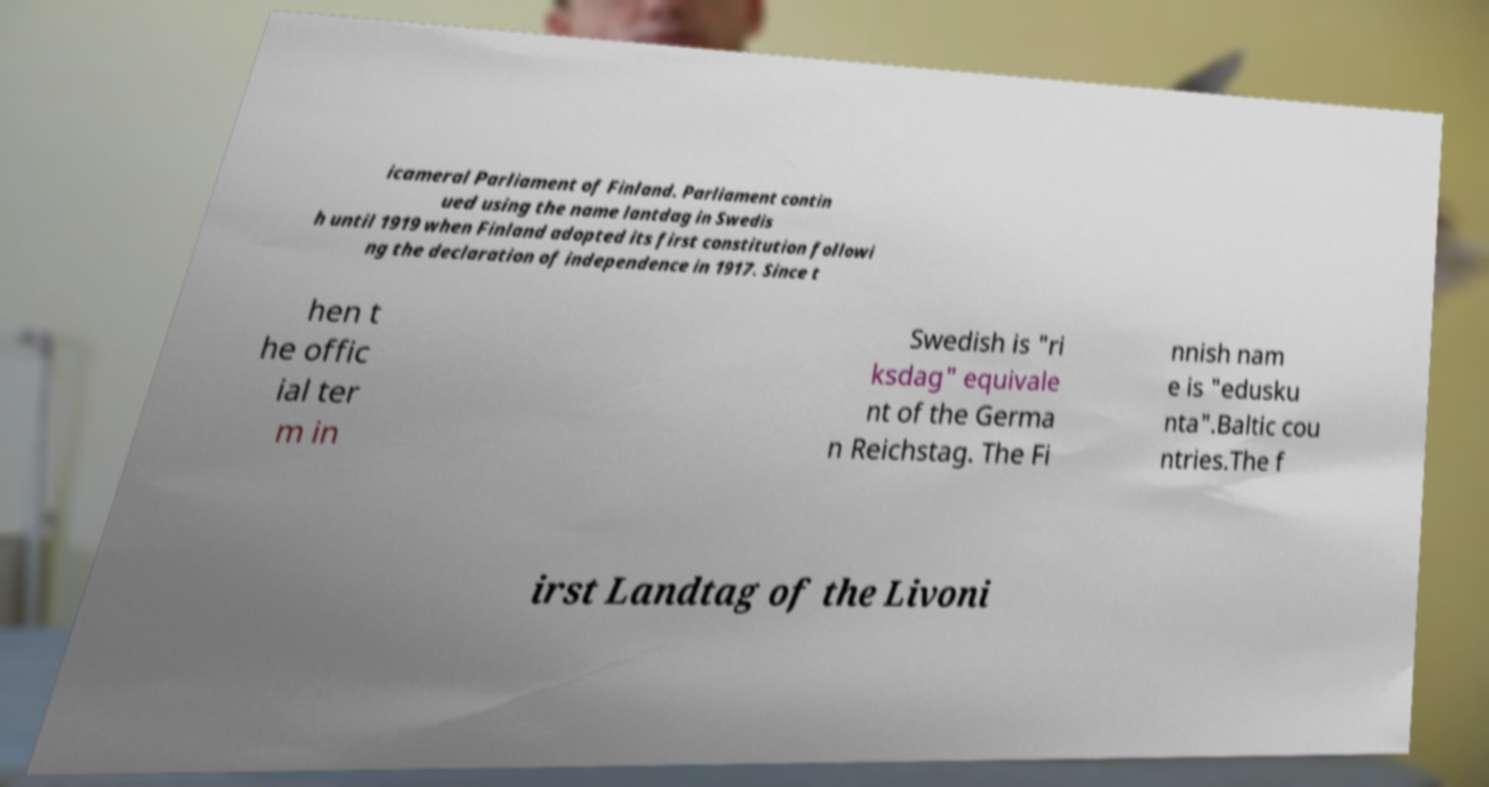Can you read and provide the text displayed in the image?This photo seems to have some interesting text. Can you extract and type it out for me? icameral Parliament of Finland. Parliament contin ued using the name lantdag in Swedis h until 1919 when Finland adopted its first constitution followi ng the declaration of independence in 1917. Since t hen t he offic ial ter m in Swedish is "ri ksdag" equivale nt of the Germa n Reichstag. The Fi nnish nam e is "edusku nta".Baltic cou ntries.The f irst Landtag of the Livoni 